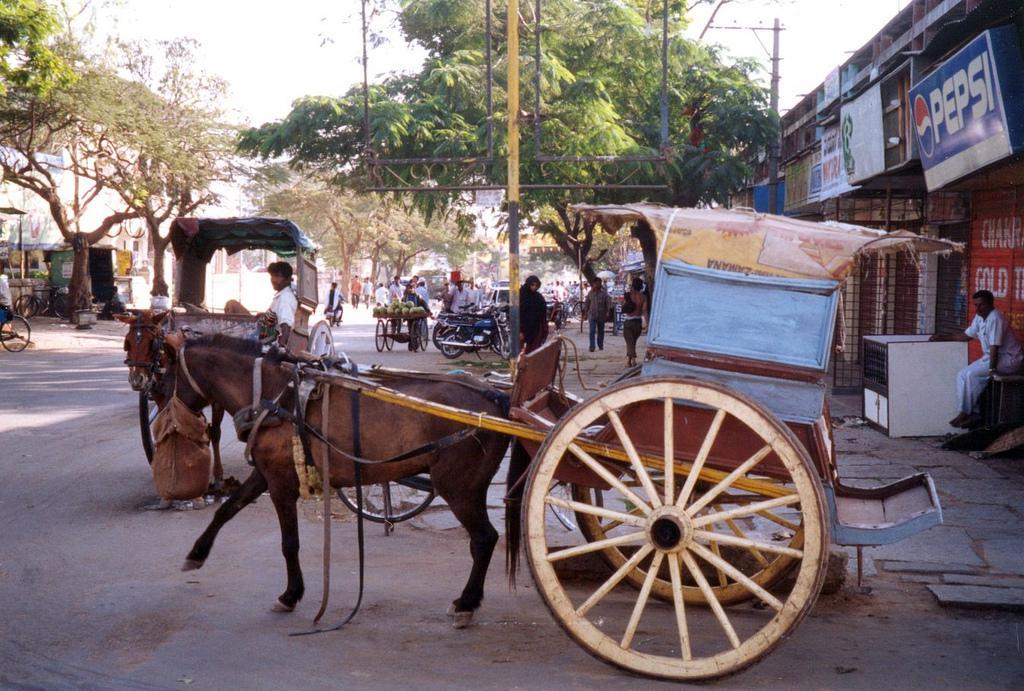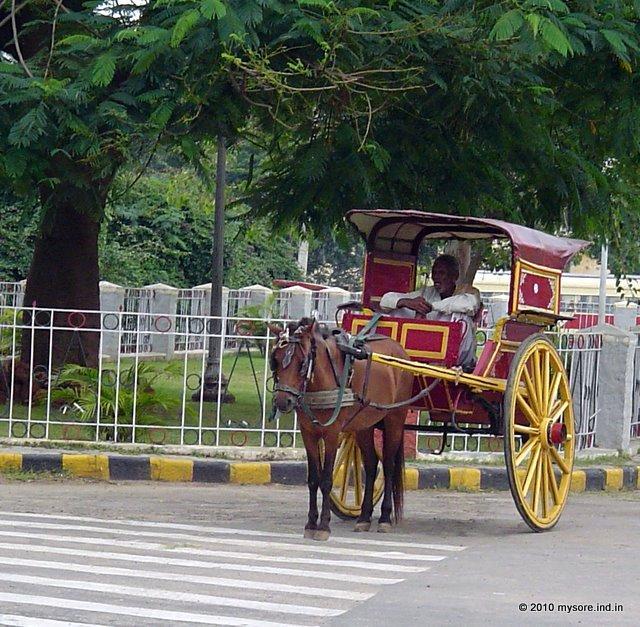The first image is the image on the left, the second image is the image on the right. Considering the images on both sides, is "The cart in one of the images is red." valid? Answer yes or no. Yes. 